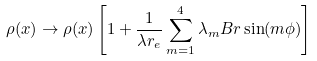Convert formula to latex. <formula><loc_0><loc_0><loc_500><loc_500>\rho ( x ) \rightarrow \rho ( x ) \left [ 1 + \frac { 1 } { \lambda r _ { e } } \sum _ { m = 1 } ^ { 4 } \lambda _ { m } B r \sin ( m \phi ) \right ]</formula> 